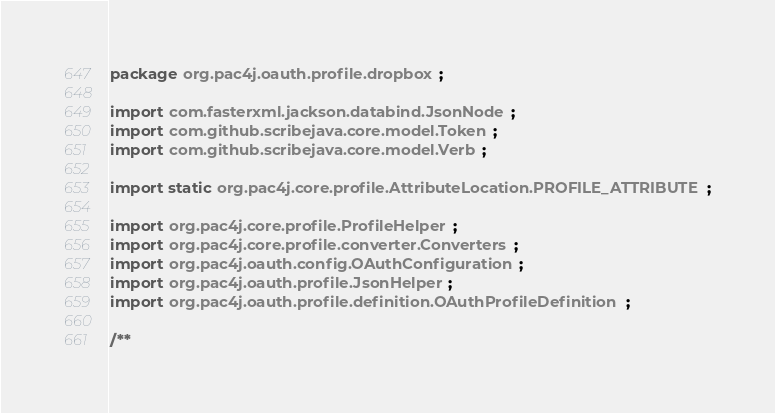<code> <loc_0><loc_0><loc_500><loc_500><_Java_>package org.pac4j.oauth.profile.dropbox;

import com.fasterxml.jackson.databind.JsonNode;
import com.github.scribejava.core.model.Token;
import com.github.scribejava.core.model.Verb;

import static org.pac4j.core.profile.AttributeLocation.PROFILE_ATTRIBUTE;

import org.pac4j.core.profile.ProfileHelper;
import org.pac4j.core.profile.converter.Converters;
import org.pac4j.oauth.config.OAuthConfiguration;
import org.pac4j.oauth.profile.JsonHelper;
import org.pac4j.oauth.profile.definition.OAuthProfileDefinition;

/**</code> 